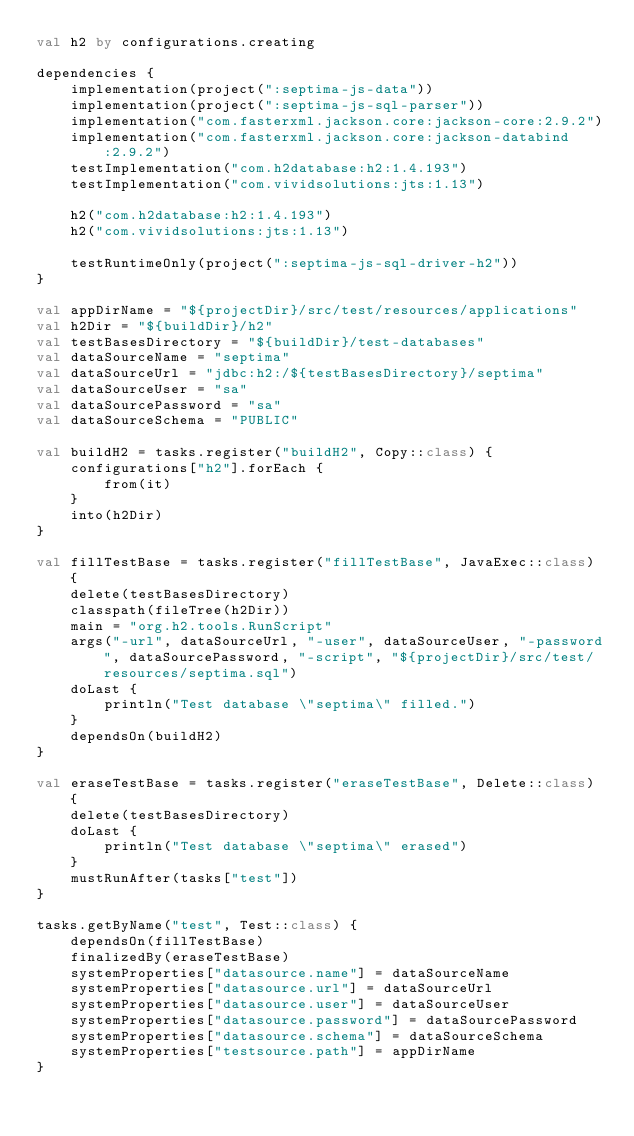<code> <loc_0><loc_0><loc_500><loc_500><_Kotlin_>val h2 by configurations.creating

dependencies {
    implementation(project(":septima-js-data"))
    implementation(project(":septima-js-sql-parser"))
    implementation("com.fasterxml.jackson.core:jackson-core:2.9.2")
    implementation("com.fasterxml.jackson.core:jackson-databind:2.9.2")
    testImplementation("com.h2database:h2:1.4.193")
    testImplementation("com.vividsolutions:jts:1.13")

    h2("com.h2database:h2:1.4.193")
    h2("com.vividsolutions:jts:1.13")
            
    testRuntimeOnly(project(":septima-js-sql-driver-h2"))
}

val appDirName = "${projectDir}/src/test/resources/applications"
val h2Dir = "${buildDir}/h2"
val testBasesDirectory = "${buildDir}/test-databases"
val dataSourceName = "septima"
val dataSourceUrl = "jdbc:h2:/${testBasesDirectory}/septima"
val dataSourceUser = "sa"
val dataSourcePassword = "sa"
val dataSourceSchema = "PUBLIC"

val buildH2 = tasks.register("buildH2", Copy::class) {
    configurations["h2"].forEach {
        from(it)
    }
    into(h2Dir)
}

val fillTestBase = tasks.register("fillTestBase", JavaExec::class) {
    delete(testBasesDirectory)
    classpath(fileTree(h2Dir))
    main = "org.h2.tools.RunScript"
    args("-url", dataSourceUrl, "-user", dataSourceUser, "-password", dataSourcePassword, "-script", "${projectDir}/src/test/resources/septima.sql")
    doLast {
        println("Test database \"septima\" filled.")
    }
    dependsOn(buildH2)
}

val eraseTestBase = tasks.register("eraseTestBase", Delete::class) {
    delete(testBasesDirectory)
    doLast {
        println("Test database \"septima\" erased")
    }
    mustRunAfter(tasks["test"])
}

tasks.getByName("test", Test::class) {
    dependsOn(fillTestBase)
    finalizedBy(eraseTestBase)
    systemProperties["datasource.name"] = dataSourceName
    systemProperties["datasource.url"] = dataSourceUrl
    systemProperties["datasource.user"] = dataSourceUser
    systemProperties["datasource.password"] = dataSourcePassword
    systemProperties["datasource.schema"] = dataSourceSchema
    systemProperties["testsource.path"] = appDirName
}
</code> 